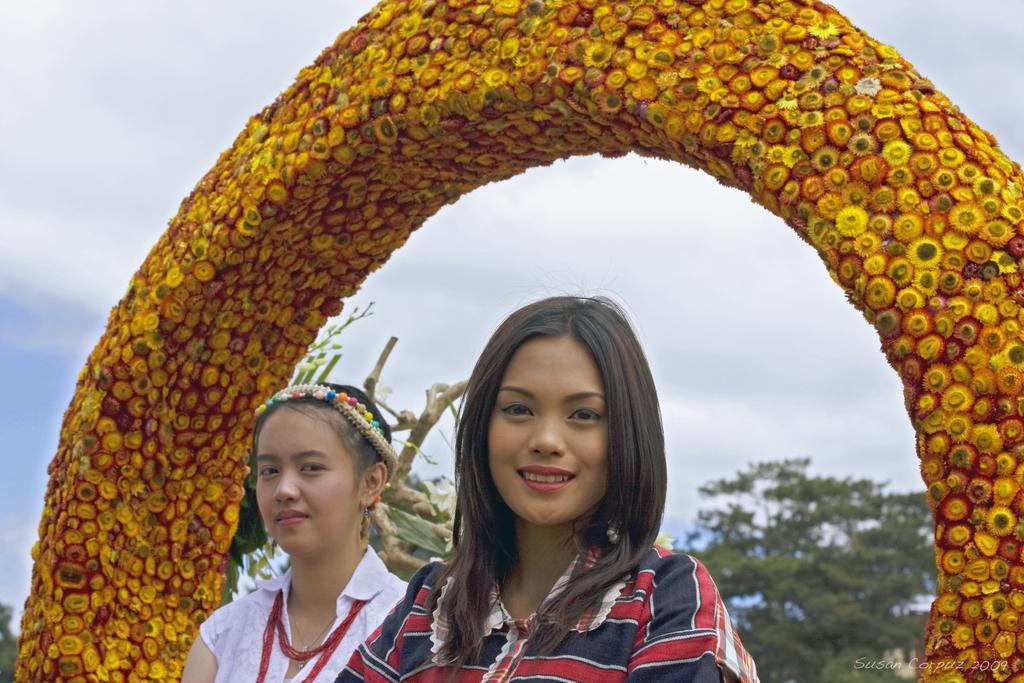In one or two sentences, can you explain what this image depicts? In the middle of the image two women are standing. Behind them there is a arch and there are some trees. Top of the image there are some clouds and sky. 